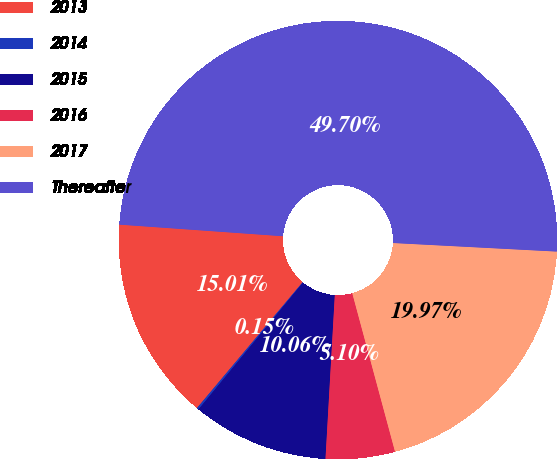<chart> <loc_0><loc_0><loc_500><loc_500><pie_chart><fcel>2013<fcel>2014<fcel>2015<fcel>2016<fcel>2017<fcel>Thereafter<nl><fcel>15.01%<fcel>0.15%<fcel>10.06%<fcel>5.1%<fcel>19.97%<fcel>49.7%<nl></chart> 